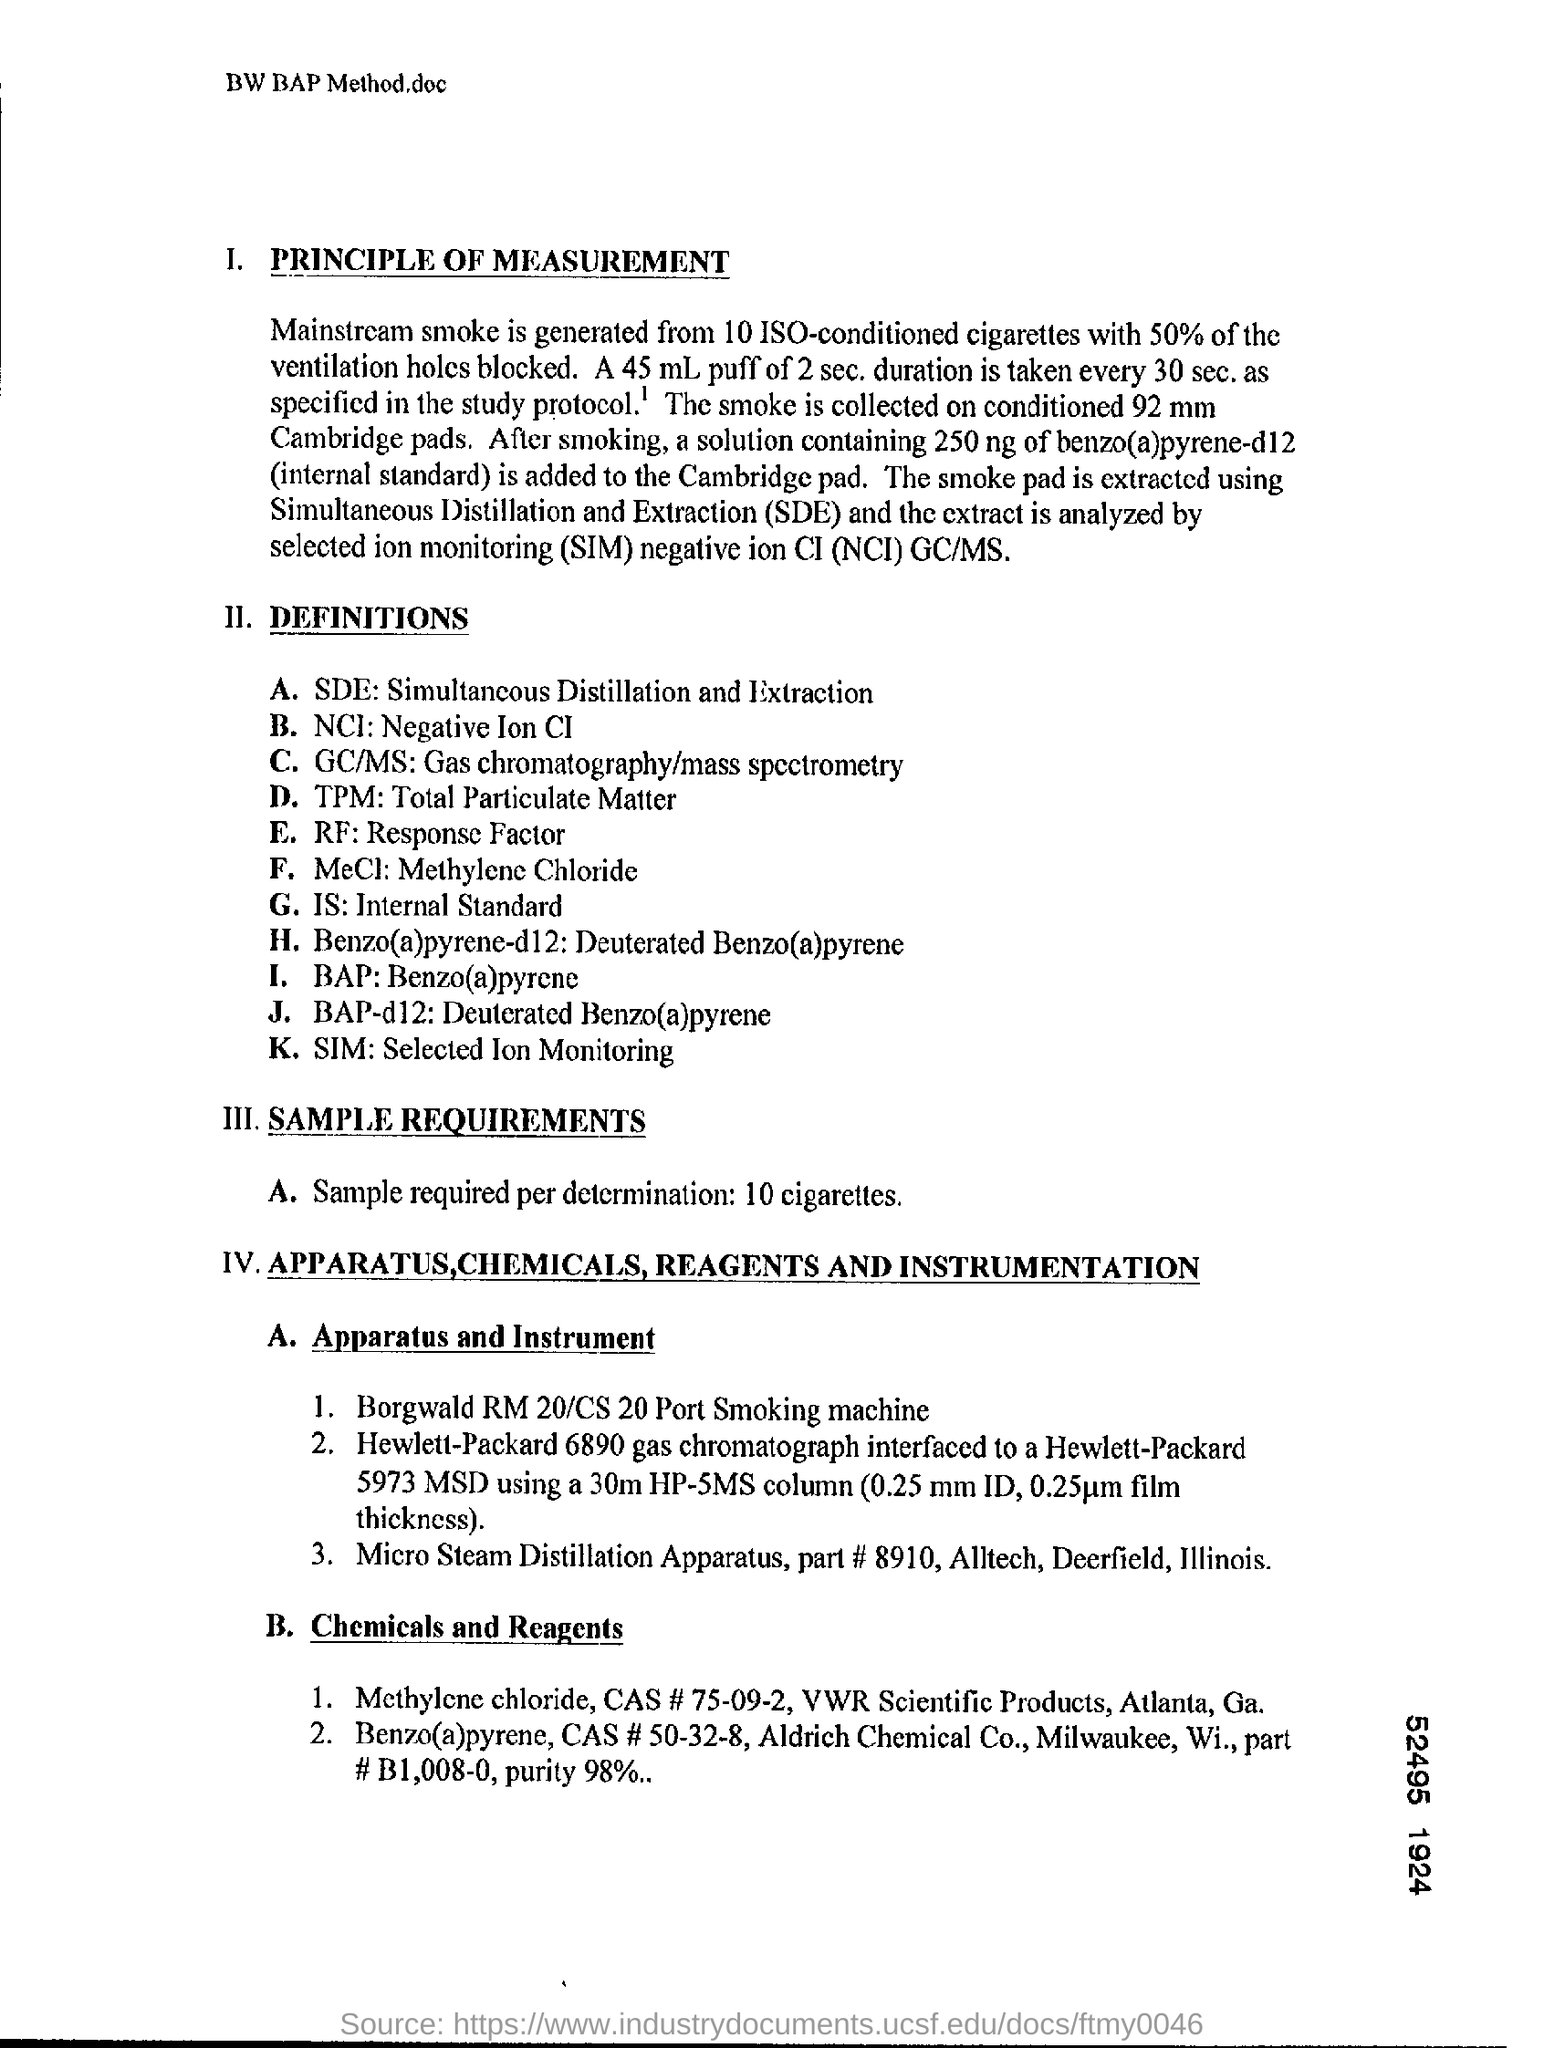List a handful of essential elements in this visual. Total Particulate Matter, commonly referred to as TPM, is a measure of the amount of small particles found in the air. Selected Ion Monitoring (SIM) is a technique that involves the use of ions that have been selected for analysis in a mass spectrometer. The full form of SIM is "Selected Ion Monitoring", which refers to the method of monitoring and analyzing ions that have been specifically selected for measurement in a mass spectrometer. Simultaneous Distillation and Extraction (SDE) is the process of simultaneously distilling and extracting substances from a liquid mixture. The full form of SDE is Simultaneous Distillation and Extraction. 